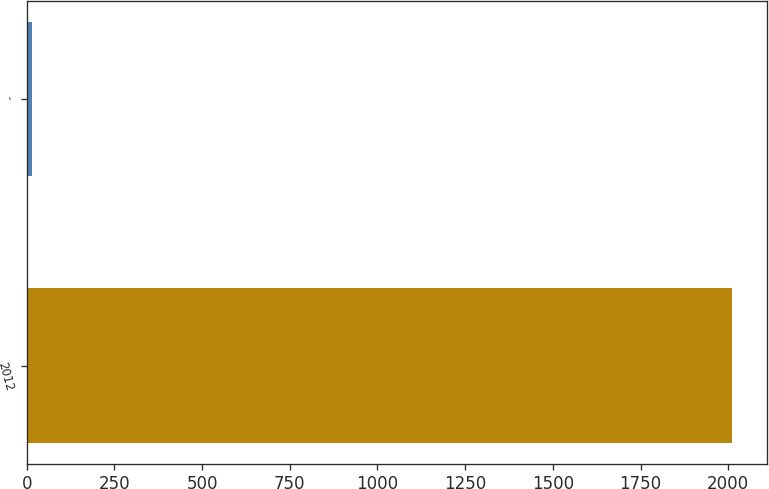Convert chart. <chart><loc_0><loc_0><loc_500><loc_500><bar_chart><fcel>2012<fcel>-<nl><fcel>2011<fcel>13.6<nl></chart> 